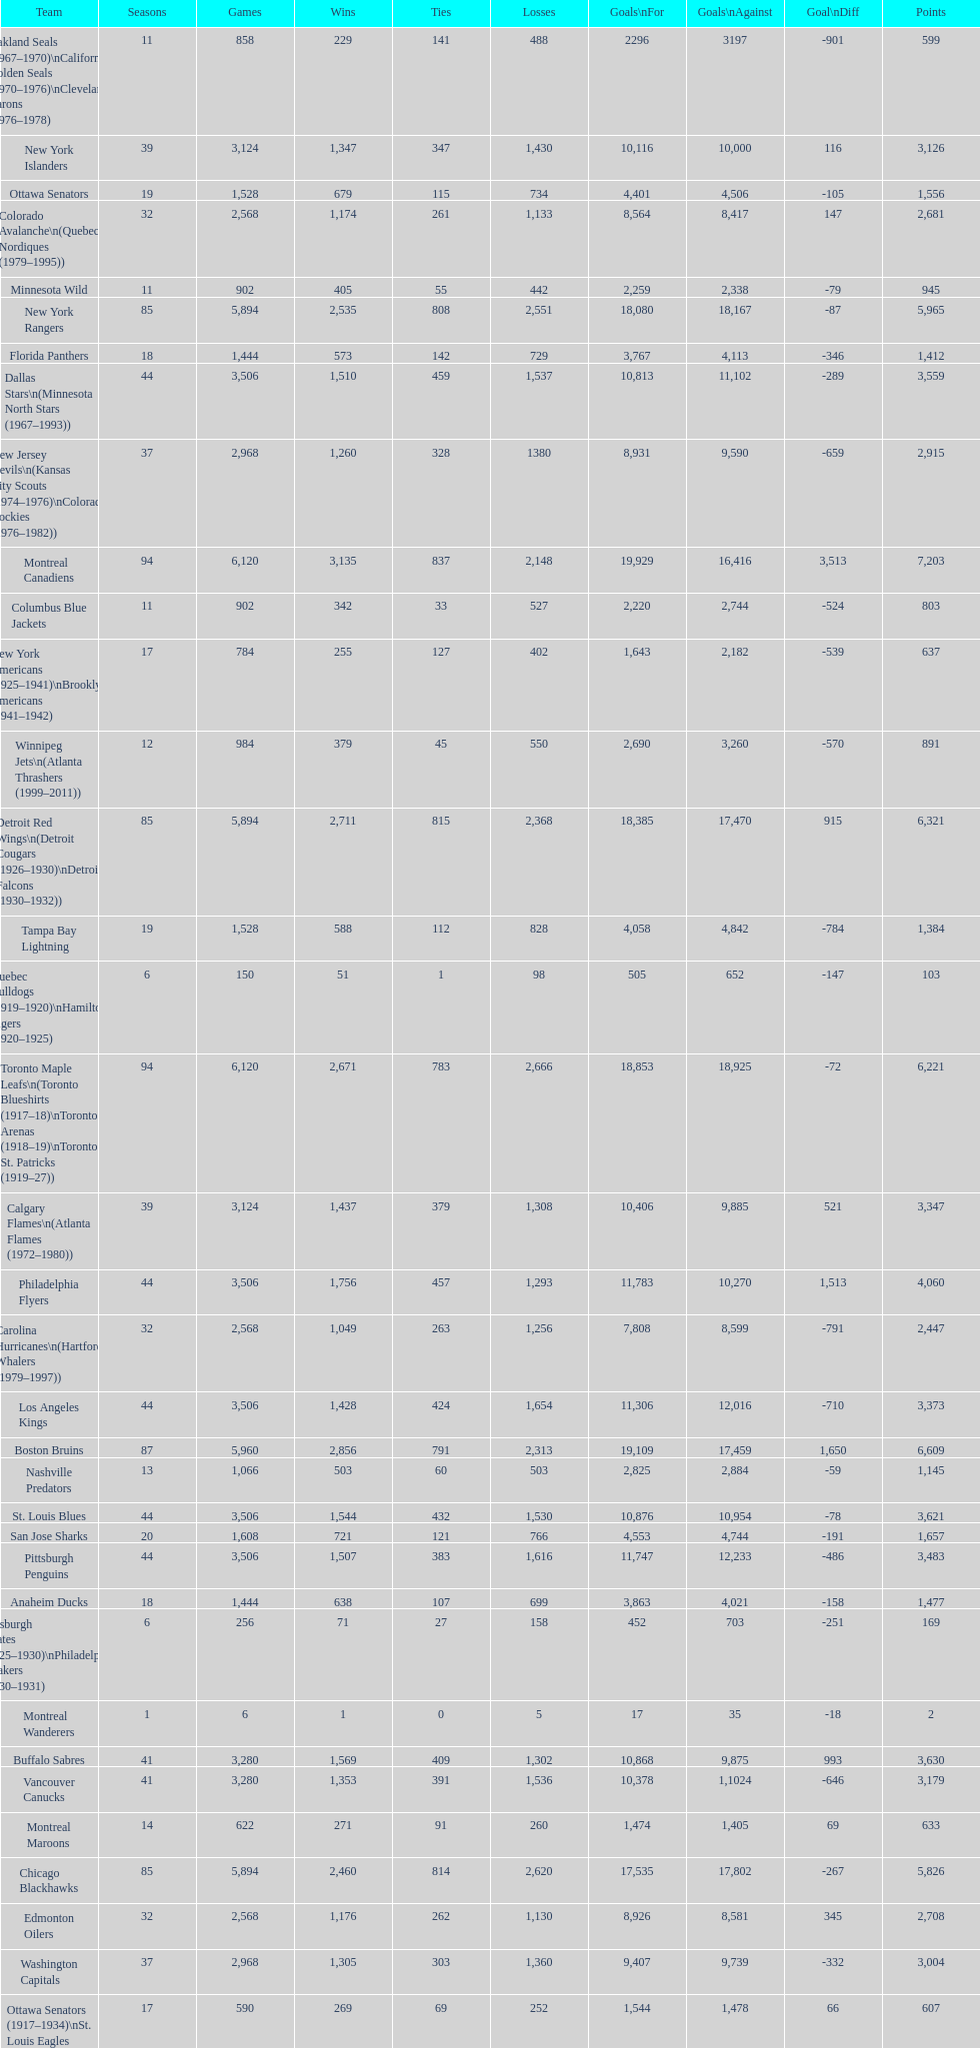How many total points has the lost angeles kings scored? 3,373. 